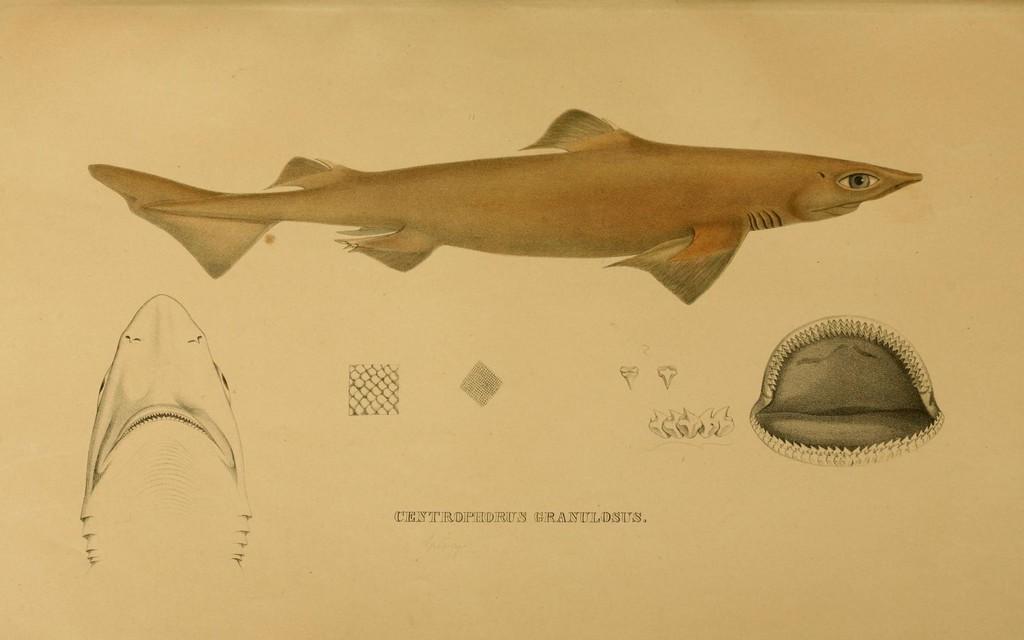Can you describe this image briefly? This is a drawing image in which there is some text and there are parts of fish and there is a fish which is visible. 